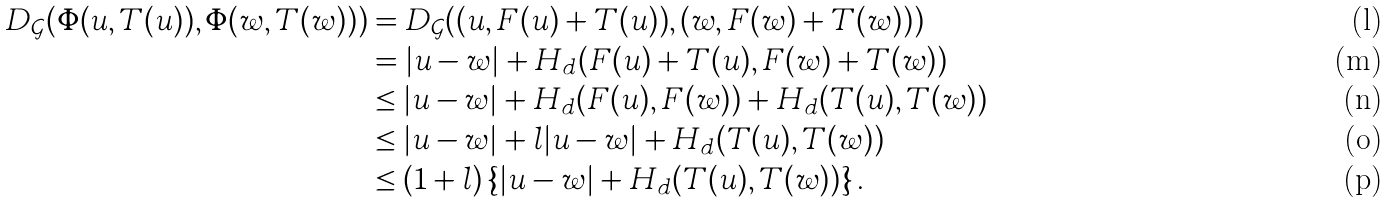Convert formula to latex. <formula><loc_0><loc_0><loc_500><loc_500>D _ { \mathcal { G } } ( \Phi ( u , T ( u ) ) , \Phi ( w , T ( w ) ) ) & = D _ { \mathcal { G } } ( ( u , F ( u ) + T ( u ) ) , ( w , F ( w ) + T ( w ) ) ) \\ & = | u - w | + H _ { d } ( F ( u ) + T ( u ) , F ( w ) + T ( w ) ) \\ & \leq | u - w | + H _ { d } ( F ( u ) , F ( w ) ) + H _ { d } ( T ( u ) , T ( w ) ) \\ & \leq | u - w | + l | u - w | + H _ { d } ( T ( u ) , T ( w ) ) \\ & \leq ( 1 + l ) \left \{ | u - w | + H _ { d } ( T ( u ) , T ( w ) ) \right \} .</formula> 